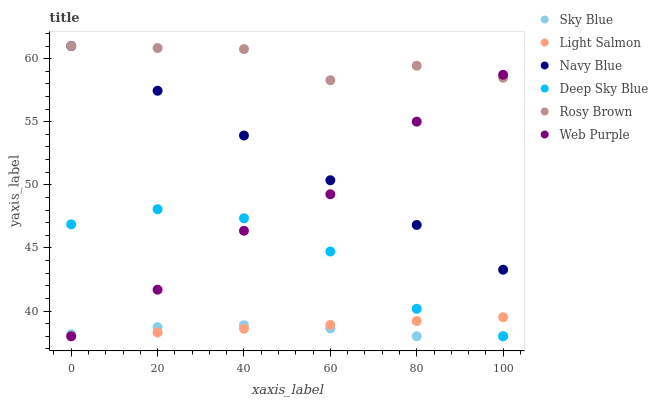Does Sky Blue have the minimum area under the curve?
Answer yes or no. Yes. Does Rosy Brown have the maximum area under the curve?
Answer yes or no. Yes. Does Navy Blue have the minimum area under the curve?
Answer yes or no. No. Does Navy Blue have the maximum area under the curve?
Answer yes or no. No. Is Light Salmon the smoothest?
Answer yes or no. Yes. Is Rosy Brown the roughest?
Answer yes or no. Yes. Is Navy Blue the smoothest?
Answer yes or no. No. Is Navy Blue the roughest?
Answer yes or no. No. Does Light Salmon have the lowest value?
Answer yes or no. Yes. Does Navy Blue have the lowest value?
Answer yes or no. No. Does Rosy Brown have the highest value?
Answer yes or no. Yes. Does Web Purple have the highest value?
Answer yes or no. No. Is Sky Blue less than Navy Blue?
Answer yes or no. Yes. Is Rosy Brown greater than Sky Blue?
Answer yes or no. Yes. Does Light Salmon intersect Deep Sky Blue?
Answer yes or no. Yes. Is Light Salmon less than Deep Sky Blue?
Answer yes or no. No. Is Light Salmon greater than Deep Sky Blue?
Answer yes or no. No. Does Sky Blue intersect Navy Blue?
Answer yes or no. No. 